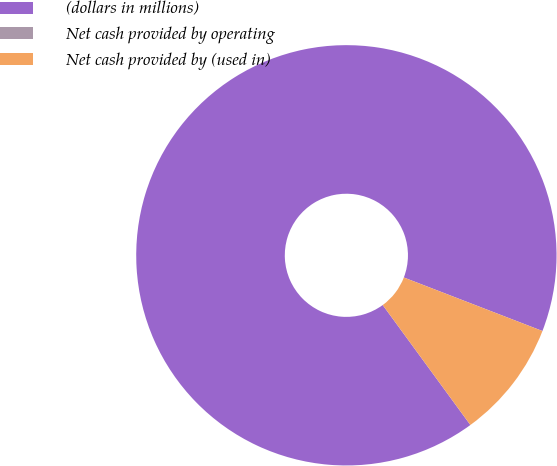Convert chart. <chart><loc_0><loc_0><loc_500><loc_500><pie_chart><fcel>(dollars in millions)<fcel>Net cash provided by operating<fcel>Net cash provided by (used in)<nl><fcel>90.91%<fcel>0.0%<fcel>9.09%<nl></chart> 